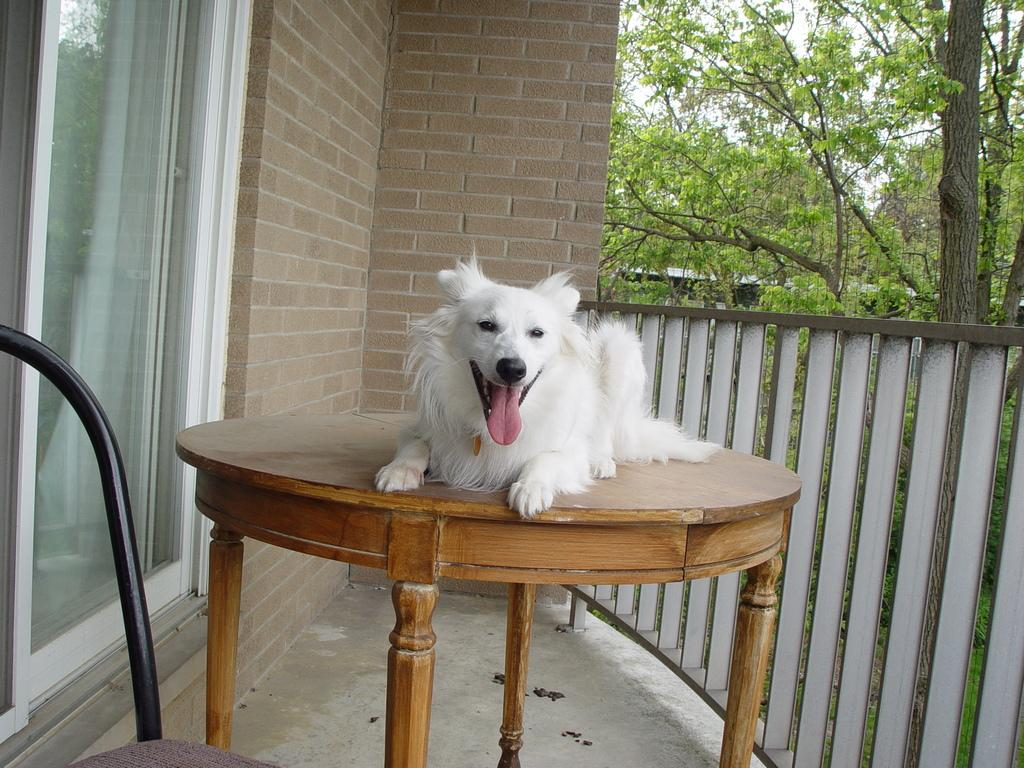What animal is sitting on the table in the image? There is a dog sitting on the table in the image. What type of door is on the left side of the image? There is a glass door on the left side of the image. What is behind the glass door? There is a brick wall behind the glass door. What type of vegetation is on the right side of the image? There are trees on the right side of the image. What is the weather like in the image? The sky is visible and appears to be sunny, suggesting a clear and bright day. Where is the ant going on the road in the image? There is no ant or road present in the image. What is the slope of the hill in the image? There is no hill or slope present in the image. 